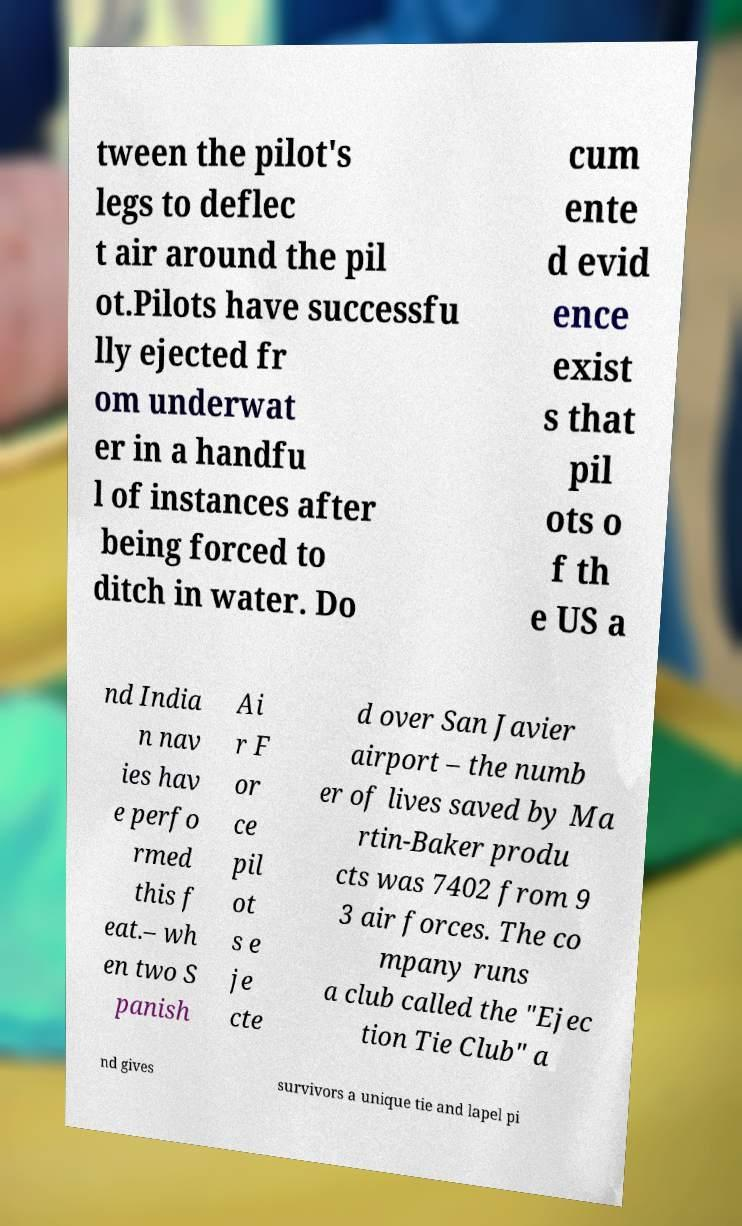Please read and relay the text visible in this image. What does it say? tween the pilot's legs to deflec t air around the pil ot.Pilots have successfu lly ejected fr om underwat er in a handfu l of instances after being forced to ditch in water. Do cum ente d evid ence exist s that pil ots o f th e US a nd India n nav ies hav e perfo rmed this f eat.– wh en two S panish Ai r F or ce pil ot s e je cte d over San Javier airport – the numb er of lives saved by Ma rtin-Baker produ cts was 7402 from 9 3 air forces. The co mpany runs a club called the "Ejec tion Tie Club" a nd gives survivors a unique tie and lapel pi 